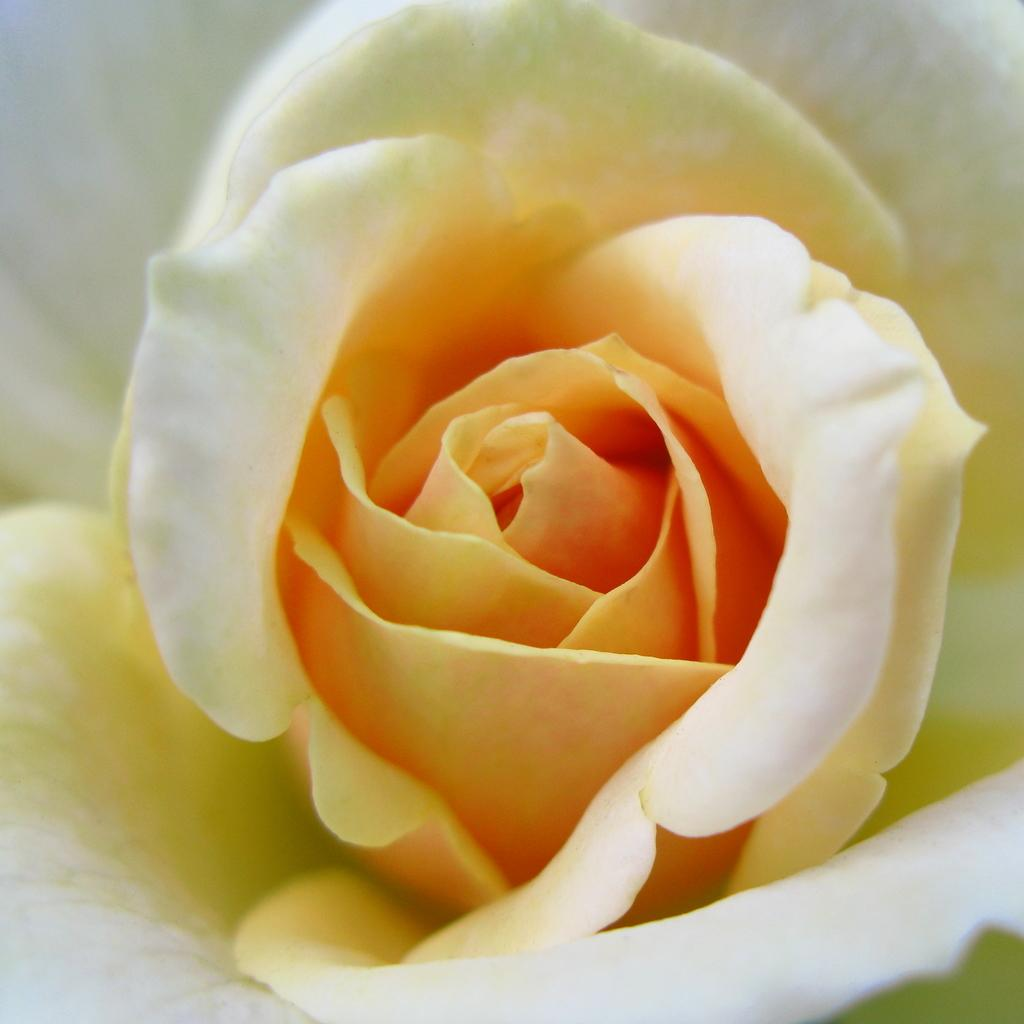What type of flower is in the image? There is a beautiful white rose in the image. Can you describe the color of the flower? The flower is white. What type of noise can be heard coming from the underwear in the image? There is no underwear present in the image, and therefore no noise can be heard. 